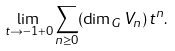Convert formula to latex. <formula><loc_0><loc_0><loc_500><loc_500>\lim _ { t \to - 1 + 0 } \sum _ { n \geq 0 } ( \dim _ { G } V _ { n } ) \, t ^ { n } .</formula> 